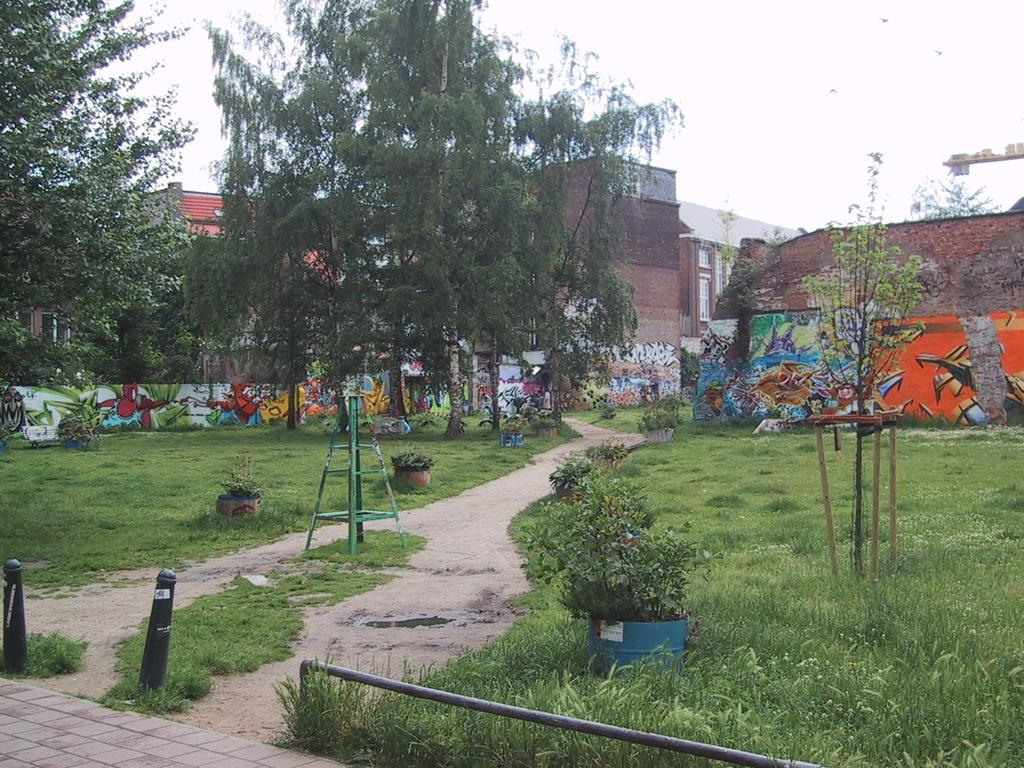What type of vegetation is present in the image? There are trees in the image. What type of structures can be seen in the image? There are buildings in the image. What type of ground cover is visible in the image? There is grass in the image. What station is responsible for controlling the trees in the image? There is no station or control system for the trees in the image; they are natural vegetation. 